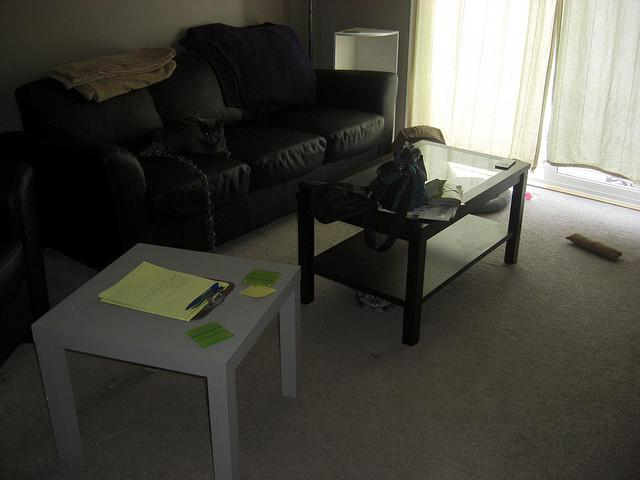What color has two post-its? green 